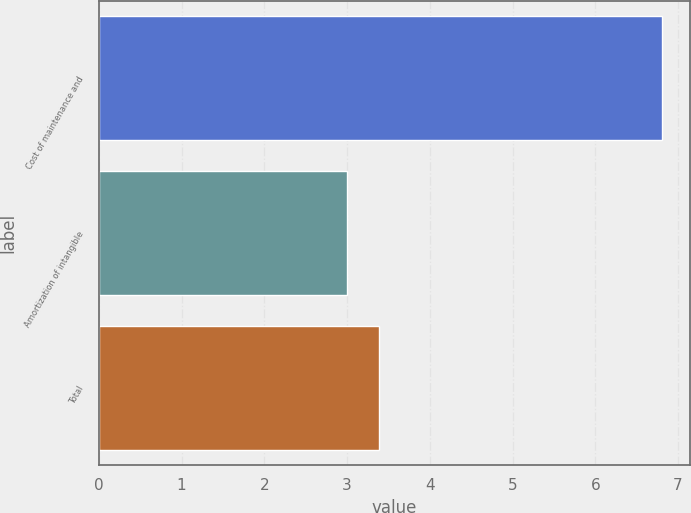Convert chart to OTSL. <chart><loc_0><loc_0><loc_500><loc_500><bar_chart><fcel>Cost of maintenance and<fcel>Amortization of intangible<fcel>Total<nl><fcel>6.8<fcel>3<fcel>3.38<nl></chart> 